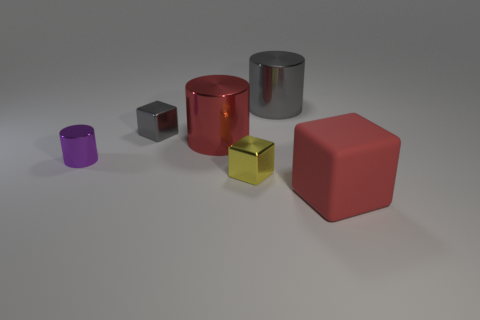Is there anything else that has the same material as the large block?
Offer a very short reply. No. There is a metal cylinder that is the same color as the large matte object; what size is it?
Make the answer very short. Large. What number of yellow blocks have the same size as the rubber thing?
Your answer should be very brief. 0. There is a big red thing left of the rubber object; is there a big gray metal object in front of it?
Offer a terse response. No. What number of things are yellow shiny cylinders or metal cylinders?
Make the answer very short. 3. There is a metallic block that is on the right side of the small cube behind the shiny cylinder that is to the left of the gray cube; what is its color?
Your answer should be very brief. Yellow. Is there any other thing that has the same color as the rubber block?
Ensure brevity in your answer.  Yes. Does the gray shiny cube have the same size as the purple metallic object?
Make the answer very short. Yes. How many things are large objects behind the large matte thing or small objects behind the purple shiny thing?
Keep it short and to the point. 3. What material is the big thing that is left of the big shiny thing behind the red cylinder made of?
Your response must be concise. Metal. 